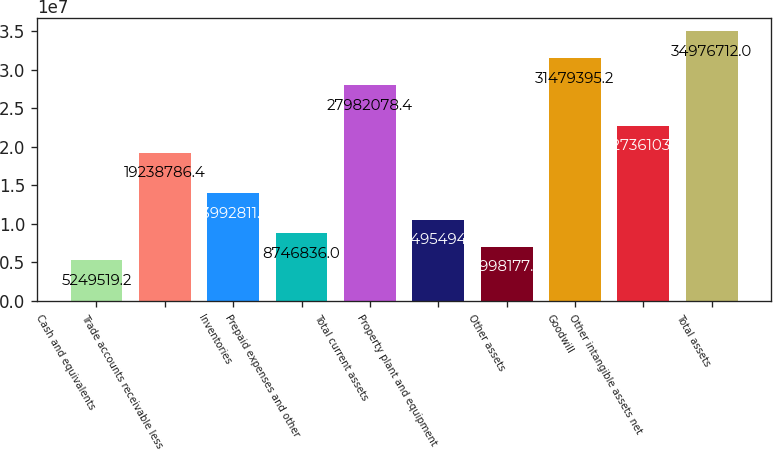Convert chart to OTSL. <chart><loc_0><loc_0><loc_500><loc_500><bar_chart><fcel>Cash and equivalents<fcel>Trade accounts receivable less<fcel>Inventories<fcel>Prepaid expenses and other<fcel>Total current assets<fcel>Property plant and equipment<fcel>Other assets<fcel>Goodwill<fcel>Other intangible assets net<fcel>Total assets<nl><fcel>5.24952e+06<fcel>1.92388e+07<fcel>1.39928e+07<fcel>8.74684e+06<fcel>2.79821e+07<fcel>1.04955e+07<fcel>6.99818e+06<fcel>3.14794e+07<fcel>2.27361e+07<fcel>3.49767e+07<nl></chart> 